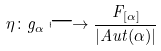Convert formula to latex. <formula><loc_0><loc_0><loc_500><loc_500>\eta \colon g _ { \alpha } \longmapsto \frac { F _ { [ \alpha ] } } { | A u t ( \alpha ) | }</formula> 